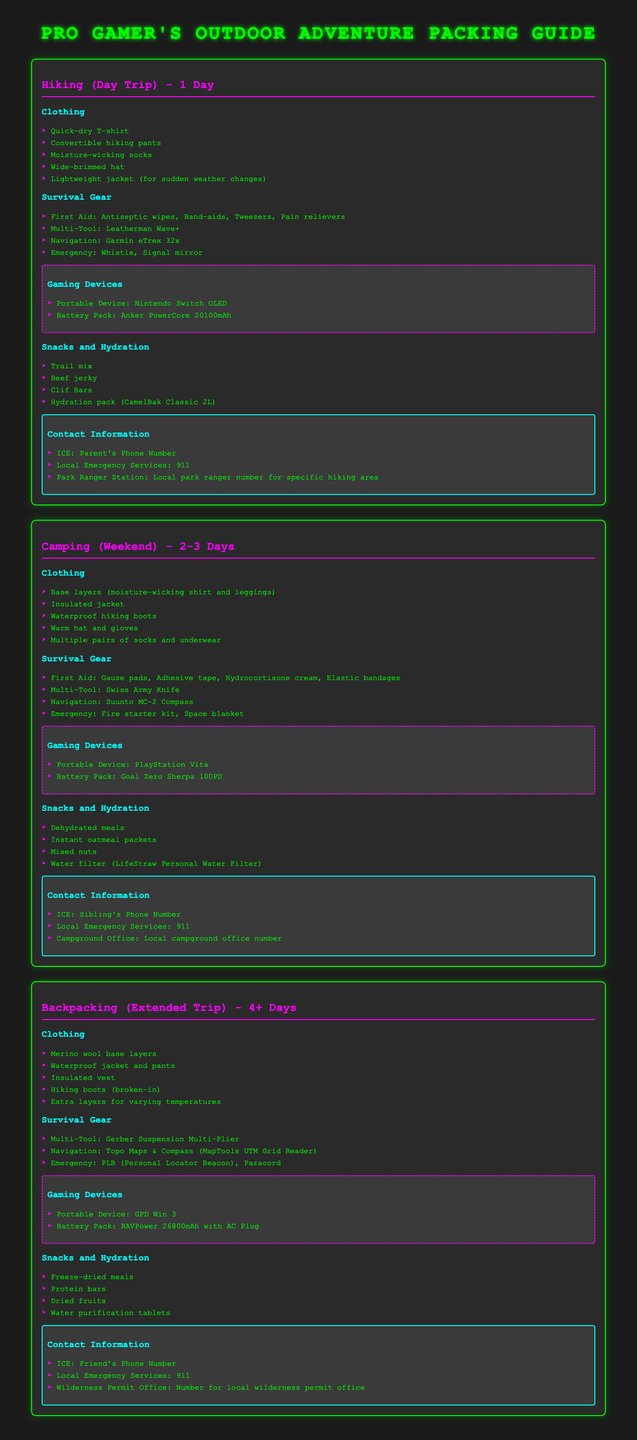What clothes are recommended for a hiking day trip? The document lists quick-dry T-shirt, convertible hiking pants, moisture-wicking socks, wide-brimmed hat, and lightweight jacket for hiking.
Answer: Quick-dry T-shirt, convertible hiking pants, moisture-wicking socks, wide-brimmed hat, lightweight jacket What is included in the survival gear for camping? The survival gear for camping includes gauze pads, adhesive tape, hydrocortisone cream, and elastic bandages.
Answer: Gauze pads, adhesive tape, hydrocortisone cream, elastic bandages How many pairs of socks are suggested for a camping weekend? The document suggests multiple pairs of socks and underwear for camping.
Answer: Multiple pairs What is the portable gaming device listed for backpacking? The portable gaming device recommended for backpacking is GPD Win 3.
Answer: GPD Win 3 What type of food is recommended for hydration while hiking? The document suggests using a hydration pack (CamelBak Classic 2L) for hydration.
Answer: Hydration pack (CamelBak Classic 2L) How many days is the backpacking trip described in the guide? The backpacking section specifies that it is for an extended trip of 4 or more days.
Answer: 4+ Days What is the contact information for local emergency services? The contact information for local emergency services provided in the document is 911.
Answer: 911 What emergency item is included for day hiking? The emergency items listed for day hiking include a whistle and a signal mirror.
Answer: Whistle, signal mirror Which portable gaming device comes with a battery pack for camping? The document mentions PlayStation Vita with Goal Zero Sherpa 100PD as the gaming device with a battery pack for camping.
Answer: PlayStation Vita 